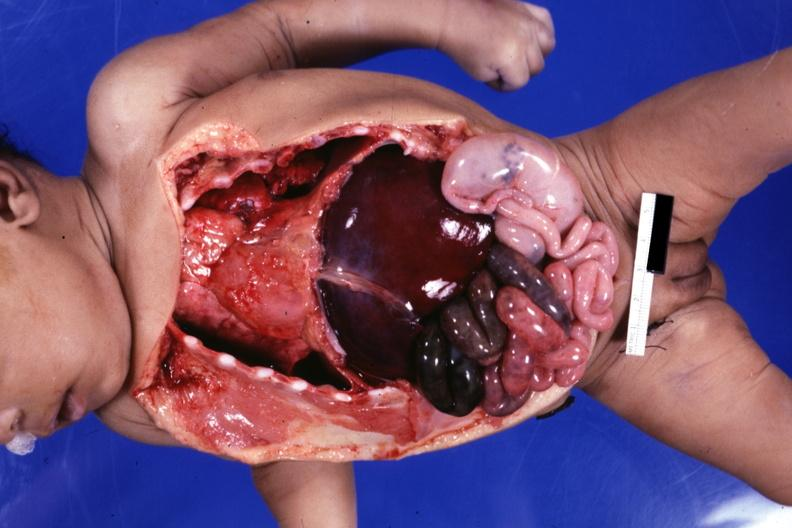does this image show infant body opened showing cardiac apex to right, right liver lobe on left cecum on left gangrenous small bowel?
Answer the question using a single word or phrase. Yes 